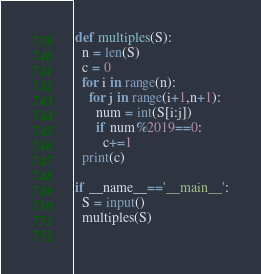<code> <loc_0><loc_0><loc_500><loc_500><_Python_>def multiples(S):
  n = len(S)
  c = 0
  for i in range(n):
    for j in range(i+1,n+1):
      num = int(S[i:j])
      if num%2019==0:
        c+=1
  print(c)

if __name__=='__main__':
  S = input()
  multiples(S)
  </code> 